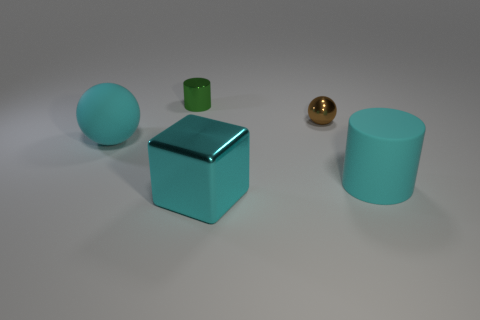Add 2 cyan cubes. How many objects exist? 7 Subtract all cylinders. How many objects are left? 3 Add 2 big cyan metal cylinders. How many big cyan metal cylinders exist? 2 Subtract 0 brown blocks. How many objects are left? 5 Subtract all tiny green metal objects. Subtract all small gray matte cubes. How many objects are left? 4 Add 5 cyan matte balls. How many cyan matte balls are left? 6 